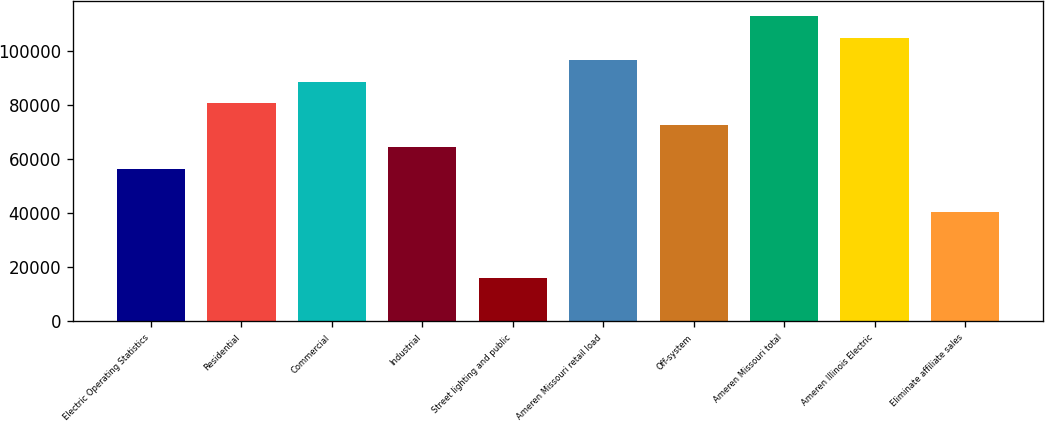<chart> <loc_0><loc_0><loc_500><loc_500><bar_chart><fcel>Electric Operating Statistics<fcel>Residential<fcel>Commercial<fcel>Industrial<fcel>Street lighting and public<fcel>Ameren Missouri retail load<fcel>Off-system<fcel>Ameren Missouri total<fcel>Ameren Illinois Electric<fcel>Eliminate affiliate sales<nl><fcel>56339.3<fcel>80468<fcel>88510.9<fcel>64382.2<fcel>16124.8<fcel>96553.8<fcel>72425.1<fcel>112640<fcel>104597<fcel>40253.5<nl></chart> 